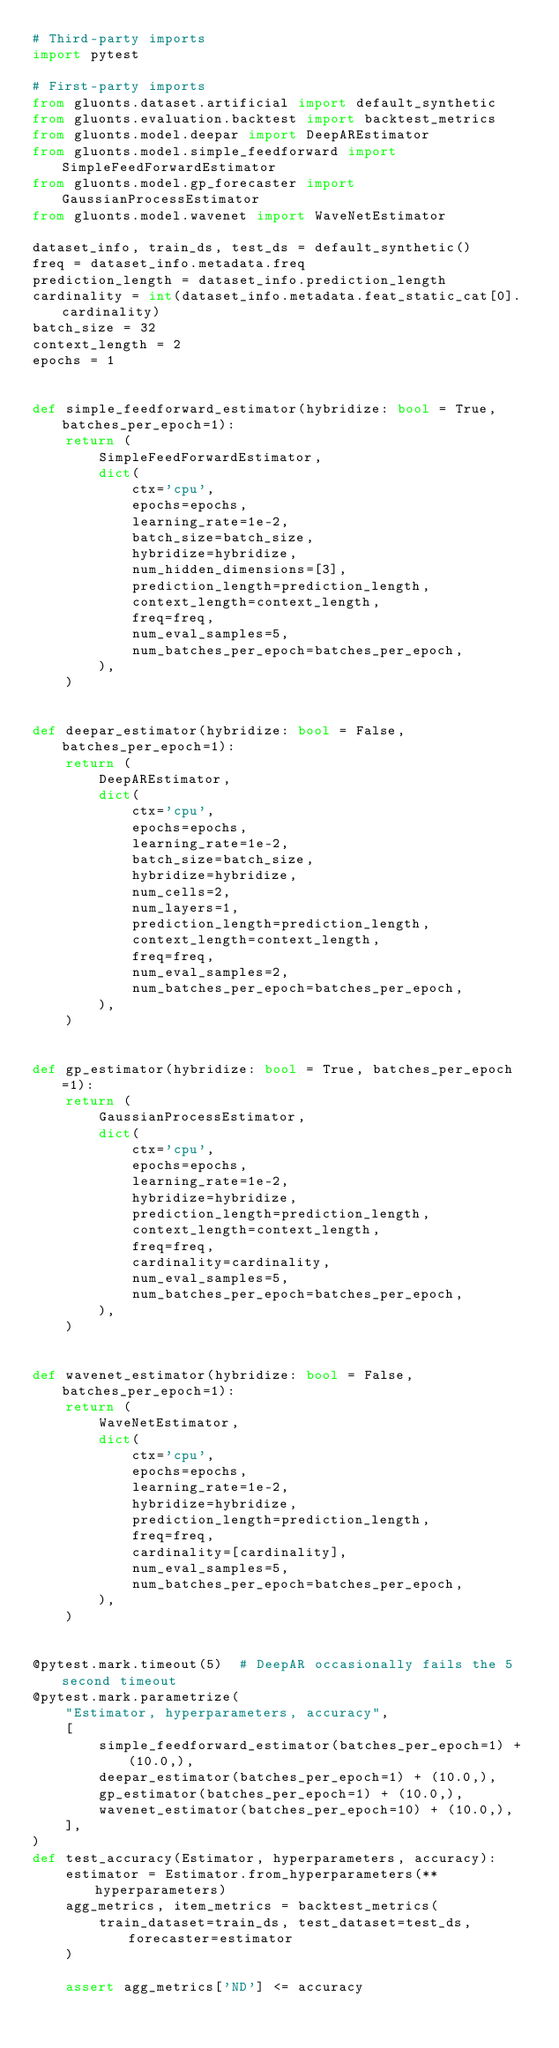<code> <loc_0><loc_0><loc_500><loc_500><_Python_># Third-party imports
import pytest

# First-party imports
from gluonts.dataset.artificial import default_synthetic
from gluonts.evaluation.backtest import backtest_metrics
from gluonts.model.deepar import DeepAREstimator
from gluonts.model.simple_feedforward import SimpleFeedForwardEstimator
from gluonts.model.gp_forecaster import GaussianProcessEstimator
from gluonts.model.wavenet import WaveNetEstimator

dataset_info, train_ds, test_ds = default_synthetic()
freq = dataset_info.metadata.freq
prediction_length = dataset_info.prediction_length
cardinality = int(dataset_info.metadata.feat_static_cat[0].cardinality)
batch_size = 32
context_length = 2
epochs = 1


def simple_feedforward_estimator(hybridize: bool = True, batches_per_epoch=1):
    return (
        SimpleFeedForwardEstimator,
        dict(
            ctx='cpu',
            epochs=epochs,
            learning_rate=1e-2,
            batch_size=batch_size,
            hybridize=hybridize,
            num_hidden_dimensions=[3],
            prediction_length=prediction_length,
            context_length=context_length,
            freq=freq,
            num_eval_samples=5,
            num_batches_per_epoch=batches_per_epoch,
        ),
    )


def deepar_estimator(hybridize: bool = False, batches_per_epoch=1):
    return (
        DeepAREstimator,
        dict(
            ctx='cpu',
            epochs=epochs,
            learning_rate=1e-2,
            batch_size=batch_size,
            hybridize=hybridize,
            num_cells=2,
            num_layers=1,
            prediction_length=prediction_length,
            context_length=context_length,
            freq=freq,
            num_eval_samples=2,
            num_batches_per_epoch=batches_per_epoch,
        ),
    )


def gp_estimator(hybridize: bool = True, batches_per_epoch=1):
    return (
        GaussianProcessEstimator,
        dict(
            ctx='cpu',
            epochs=epochs,
            learning_rate=1e-2,
            hybridize=hybridize,
            prediction_length=prediction_length,
            context_length=context_length,
            freq=freq,
            cardinality=cardinality,
            num_eval_samples=5,
            num_batches_per_epoch=batches_per_epoch,
        ),
    )


def wavenet_estimator(hybridize: bool = False, batches_per_epoch=1):
    return (
        WaveNetEstimator,
        dict(
            ctx='cpu',
            epochs=epochs,
            learning_rate=1e-2,
            hybridize=hybridize,
            prediction_length=prediction_length,
            freq=freq,
            cardinality=[cardinality],
            num_eval_samples=5,
            num_batches_per_epoch=batches_per_epoch,
        ),
    )


@pytest.mark.timeout(5)  # DeepAR occasionally fails the 5 second timeout
@pytest.mark.parametrize(
    "Estimator, hyperparameters, accuracy",
    [
        simple_feedforward_estimator(batches_per_epoch=1) + (10.0,),
        deepar_estimator(batches_per_epoch=1) + (10.0,),
        gp_estimator(batches_per_epoch=1) + (10.0,),
        wavenet_estimator(batches_per_epoch=10) + (10.0,),
    ],
)
def test_accuracy(Estimator, hyperparameters, accuracy):
    estimator = Estimator.from_hyperparameters(**hyperparameters)
    agg_metrics, item_metrics = backtest_metrics(
        train_dataset=train_ds, test_dataset=test_ds, forecaster=estimator
    )

    assert agg_metrics['ND'] <= accuracy
</code> 